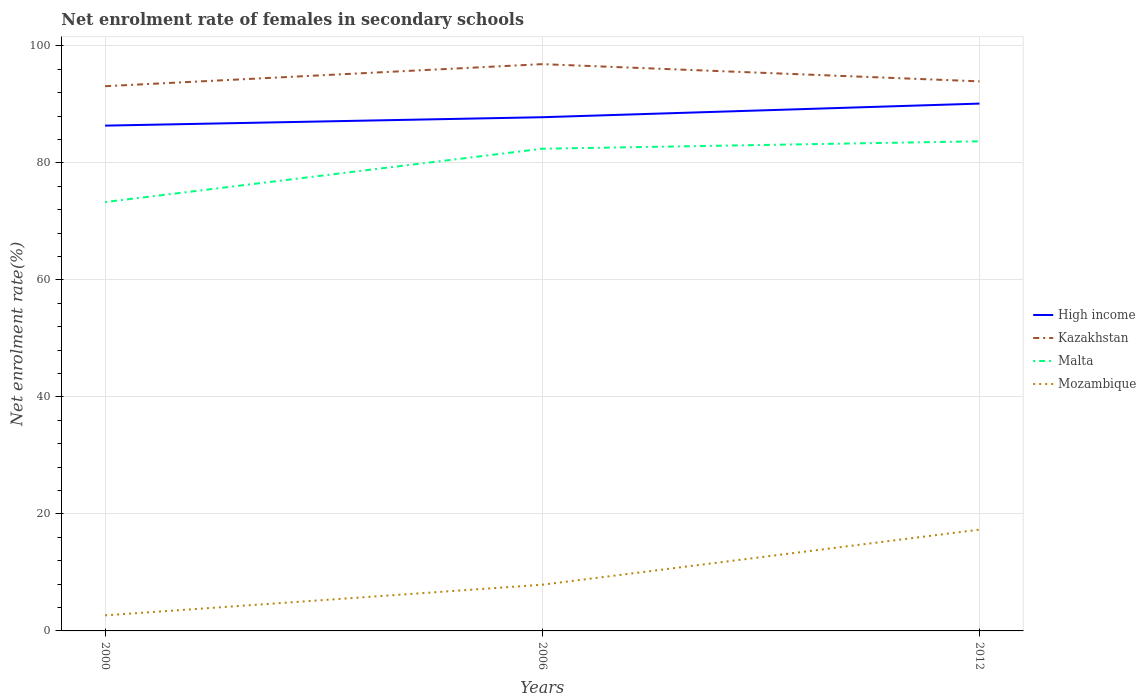How many different coloured lines are there?
Provide a short and direct response. 4. Is the number of lines equal to the number of legend labels?
Your answer should be compact. Yes. Across all years, what is the maximum net enrolment rate of females in secondary schools in High income?
Ensure brevity in your answer.  86.38. In which year was the net enrolment rate of females in secondary schools in Malta maximum?
Provide a short and direct response. 2000. What is the total net enrolment rate of females in secondary schools in Mozambique in the graph?
Your answer should be compact. -9.42. What is the difference between the highest and the second highest net enrolment rate of females in secondary schools in High income?
Your answer should be very brief. 3.76. Is the net enrolment rate of females in secondary schools in Malta strictly greater than the net enrolment rate of females in secondary schools in Mozambique over the years?
Provide a succinct answer. No. How many lines are there?
Provide a succinct answer. 4. How many years are there in the graph?
Provide a succinct answer. 3. How are the legend labels stacked?
Offer a terse response. Vertical. What is the title of the graph?
Your answer should be compact. Net enrolment rate of females in secondary schools. Does "Latin America(all income levels)" appear as one of the legend labels in the graph?
Make the answer very short. No. What is the label or title of the Y-axis?
Your answer should be compact. Net enrolment rate(%). What is the Net enrolment rate(%) in High income in 2000?
Your answer should be very brief. 86.38. What is the Net enrolment rate(%) of Kazakhstan in 2000?
Offer a terse response. 93.11. What is the Net enrolment rate(%) of Malta in 2000?
Offer a terse response. 73.31. What is the Net enrolment rate(%) of Mozambique in 2000?
Ensure brevity in your answer.  2.66. What is the Net enrolment rate(%) of High income in 2006?
Offer a very short reply. 87.81. What is the Net enrolment rate(%) of Kazakhstan in 2006?
Provide a succinct answer. 96.89. What is the Net enrolment rate(%) of Malta in 2006?
Keep it short and to the point. 82.43. What is the Net enrolment rate(%) of Mozambique in 2006?
Keep it short and to the point. 7.9. What is the Net enrolment rate(%) in High income in 2012?
Give a very brief answer. 90.14. What is the Net enrolment rate(%) in Kazakhstan in 2012?
Ensure brevity in your answer.  93.94. What is the Net enrolment rate(%) in Malta in 2012?
Offer a very short reply. 83.7. What is the Net enrolment rate(%) in Mozambique in 2012?
Offer a very short reply. 17.32. Across all years, what is the maximum Net enrolment rate(%) in High income?
Offer a terse response. 90.14. Across all years, what is the maximum Net enrolment rate(%) of Kazakhstan?
Keep it short and to the point. 96.89. Across all years, what is the maximum Net enrolment rate(%) in Malta?
Your response must be concise. 83.7. Across all years, what is the maximum Net enrolment rate(%) of Mozambique?
Give a very brief answer. 17.32. Across all years, what is the minimum Net enrolment rate(%) of High income?
Give a very brief answer. 86.38. Across all years, what is the minimum Net enrolment rate(%) in Kazakhstan?
Provide a short and direct response. 93.11. Across all years, what is the minimum Net enrolment rate(%) in Malta?
Provide a succinct answer. 73.31. Across all years, what is the minimum Net enrolment rate(%) in Mozambique?
Offer a very short reply. 2.66. What is the total Net enrolment rate(%) in High income in the graph?
Give a very brief answer. 264.33. What is the total Net enrolment rate(%) of Kazakhstan in the graph?
Keep it short and to the point. 283.95. What is the total Net enrolment rate(%) in Malta in the graph?
Give a very brief answer. 239.43. What is the total Net enrolment rate(%) of Mozambique in the graph?
Keep it short and to the point. 27.87. What is the difference between the Net enrolment rate(%) in High income in 2000 and that in 2006?
Your response must be concise. -1.44. What is the difference between the Net enrolment rate(%) of Kazakhstan in 2000 and that in 2006?
Provide a succinct answer. -3.77. What is the difference between the Net enrolment rate(%) in Malta in 2000 and that in 2006?
Make the answer very short. -9.12. What is the difference between the Net enrolment rate(%) of Mozambique in 2000 and that in 2006?
Keep it short and to the point. -5.24. What is the difference between the Net enrolment rate(%) of High income in 2000 and that in 2012?
Your response must be concise. -3.76. What is the difference between the Net enrolment rate(%) in Kazakhstan in 2000 and that in 2012?
Ensure brevity in your answer.  -0.83. What is the difference between the Net enrolment rate(%) of Malta in 2000 and that in 2012?
Provide a succinct answer. -10.39. What is the difference between the Net enrolment rate(%) in Mozambique in 2000 and that in 2012?
Your answer should be compact. -14.65. What is the difference between the Net enrolment rate(%) in High income in 2006 and that in 2012?
Offer a very short reply. -2.33. What is the difference between the Net enrolment rate(%) in Kazakhstan in 2006 and that in 2012?
Provide a short and direct response. 2.94. What is the difference between the Net enrolment rate(%) of Malta in 2006 and that in 2012?
Provide a succinct answer. -1.27. What is the difference between the Net enrolment rate(%) of Mozambique in 2006 and that in 2012?
Keep it short and to the point. -9.42. What is the difference between the Net enrolment rate(%) of High income in 2000 and the Net enrolment rate(%) of Kazakhstan in 2006?
Keep it short and to the point. -10.51. What is the difference between the Net enrolment rate(%) of High income in 2000 and the Net enrolment rate(%) of Malta in 2006?
Give a very brief answer. 3.95. What is the difference between the Net enrolment rate(%) of High income in 2000 and the Net enrolment rate(%) of Mozambique in 2006?
Your answer should be very brief. 78.48. What is the difference between the Net enrolment rate(%) in Kazakhstan in 2000 and the Net enrolment rate(%) in Malta in 2006?
Provide a succinct answer. 10.69. What is the difference between the Net enrolment rate(%) in Kazakhstan in 2000 and the Net enrolment rate(%) in Mozambique in 2006?
Keep it short and to the point. 85.22. What is the difference between the Net enrolment rate(%) in Malta in 2000 and the Net enrolment rate(%) in Mozambique in 2006?
Make the answer very short. 65.41. What is the difference between the Net enrolment rate(%) in High income in 2000 and the Net enrolment rate(%) in Kazakhstan in 2012?
Your answer should be very brief. -7.57. What is the difference between the Net enrolment rate(%) of High income in 2000 and the Net enrolment rate(%) of Malta in 2012?
Give a very brief answer. 2.68. What is the difference between the Net enrolment rate(%) of High income in 2000 and the Net enrolment rate(%) of Mozambique in 2012?
Keep it short and to the point. 69.06. What is the difference between the Net enrolment rate(%) of Kazakhstan in 2000 and the Net enrolment rate(%) of Malta in 2012?
Your answer should be very brief. 9.42. What is the difference between the Net enrolment rate(%) of Kazakhstan in 2000 and the Net enrolment rate(%) of Mozambique in 2012?
Your response must be concise. 75.8. What is the difference between the Net enrolment rate(%) of Malta in 2000 and the Net enrolment rate(%) of Mozambique in 2012?
Your answer should be compact. 55.99. What is the difference between the Net enrolment rate(%) in High income in 2006 and the Net enrolment rate(%) in Kazakhstan in 2012?
Give a very brief answer. -6.13. What is the difference between the Net enrolment rate(%) of High income in 2006 and the Net enrolment rate(%) of Malta in 2012?
Give a very brief answer. 4.11. What is the difference between the Net enrolment rate(%) of High income in 2006 and the Net enrolment rate(%) of Mozambique in 2012?
Provide a short and direct response. 70.5. What is the difference between the Net enrolment rate(%) in Kazakhstan in 2006 and the Net enrolment rate(%) in Malta in 2012?
Ensure brevity in your answer.  13.19. What is the difference between the Net enrolment rate(%) in Kazakhstan in 2006 and the Net enrolment rate(%) in Mozambique in 2012?
Provide a short and direct response. 79.57. What is the difference between the Net enrolment rate(%) in Malta in 2006 and the Net enrolment rate(%) in Mozambique in 2012?
Keep it short and to the point. 65.11. What is the average Net enrolment rate(%) in High income per year?
Offer a terse response. 88.11. What is the average Net enrolment rate(%) in Kazakhstan per year?
Provide a short and direct response. 94.65. What is the average Net enrolment rate(%) of Malta per year?
Keep it short and to the point. 79.81. What is the average Net enrolment rate(%) of Mozambique per year?
Provide a succinct answer. 9.29. In the year 2000, what is the difference between the Net enrolment rate(%) in High income and Net enrolment rate(%) in Kazakhstan?
Give a very brief answer. -6.74. In the year 2000, what is the difference between the Net enrolment rate(%) of High income and Net enrolment rate(%) of Malta?
Offer a very short reply. 13.07. In the year 2000, what is the difference between the Net enrolment rate(%) in High income and Net enrolment rate(%) in Mozambique?
Offer a very short reply. 83.71. In the year 2000, what is the difference between the Net enrolment rate(%) in Kazakhstan and Net enrolment rate(%) in Malta?
Make the answer very short. 19.81. In the year 2000, what is the difference between the Net enrolment rate(%) of Kazakhstan and Net enrolment rate(%) of Mozambique?
Offer a very short reply. 90.45. In the year 2000, what is the difference between the Net enrolment rate(%) in Malta and Net enrolment rate(%) in Mozambique?
Your response must be concise. 70.65. In the year 2006, what is the difference between the Net enrolment rate(%) of High income and Net enrolment rate(%) of Kazakhstan?
Offer a terse response. -9.07. In the year 2006, what is the difference between the Net enrolment rate(%) in High income and Net enrolment rate(%) in Malta?
Make the answer very short. 5.39. In the year 2006, what is the difference between the Net enrolment rate(%) of High income and Net enrolment rate(%) of Mozambique?
Provide a succinct answer. 79.92. In the year 2006, what is the difference between the Net enrolment rate(%) of Kazakhstan and Net enrolment rate(%) of Malta?
Ensure brevity in your answer.  14.46. In the year 2006, what is the difference between the Net enrolment rate(%) of Kazakhstan and Net enrolment rate(%) of Mozambique?
Your answer should be very brief. 88.99. In the year 2006, what is the difference between the Net enrolment rate(%) of Malta and Net enrolment rate(%) of Mozambique?
Provide a succinct answer. 74.53. In the year 2012, what is the difference between the Net enrolment rate(%) in High income and Net enrolment rate(%) in Kazakhstan?
Provide a succinct answer. -3.8. In the year 2012, what is the difference between the Net enrolment rate(%) of High income and Net enrolment rate(%) of Malta?
Provide a succinct answer. 6.44. In the year 2012, what is the difference between the Net enrolment rate(%) in High income and Net enrolment rate(%) in Mozambique?
Provide a succinct answer. 72.82. In the year 2012, what is the difference between the Net enrolment rate(%) in Kazakhstan and Net enrolment rate(%) in Malta?
Offer a terse response. 10.25. In the year 2012, what is the difference between the Net enrolment rate(%) in Kazakhstan and Net enrolment rate(%) in Mozambique?
Provide a succinct answer. 76.63. In the year 2012, what is the difference between the Net enrolment rate(%) in Malta and Net enrolment rate(%) in Mozambique?
Provide a succinct answer. 66.38. What is the ratio of the Net enrolment rate(%) of High income in 2000 to that in 2006?
Make the answer very short. 0.98. What is the ratio of the Net enrolment rate(%) in Kazakhstan in 2000 to that in 2006?
Your answer should be very brief. 0.96. What is the ratio of the Net enrolment rate(%) in Malta in 2000 to that in 2006?
Give a very brief answer. 0.89. What is the ratio of the Net enrolment rate(%) of Mozambique in 2000 to that in 2006?
Give a very brief answer. 0.34. What is the ratio of the Net enrolment rate(%) of High income in 2000 to that in 2012?
Provide a succinct answer. 0.96. What is the ratio of the Net enrolment rate(%) of Kazakhstan in 2000 to that in 2012?
Offer a terse response. 0.99. What is the ratio of the Net enrolment rate(%) in Malta in 2000 to that in 2012?
Provide a short and direct response. 0.88. What is the ratio of the Net enrolment rate(%) in Mozambique in 2000 to that in 2012?
Provide a short and direct response. 0.15. What is the ratio of the Net enrolment rate(%) in High income in 2006 to that in 2012?
Your response must be concise. 0.97. What is the ratio of the Net enrolment rate(%) in Kazakhstan in 2006 to that in 2012?
Your answer should be compact. 1.03. What is the ratio of the Net enrolment rate(%) of Mozambique in 2006 to that in 2012?
Your response must be concise. 0.46. What is the difference between the highest and the second highest Net enrolment rate(%) in High income?
Make the answer very short. 2.33. What is the difference between the highest and the second highest Net enrolment rate(%) in Kazakhstan?
Give a very brief answer. 2.94. What is the difference between the highest and the second highest Net enrolment rate(%) of Malta?
Make the answer very short. 1.27. What is the difference between the highest and the second highest Net enrolment rate(%) in Mozambique?
Give a very brief answer. 9.42. What is the difference between the highest and the lowest Net enrolment rate(%) of High income?
Your response must be concise. 3.76. What is the difference between the highest and the lowest Net enrolment rate(%) in Kazakhstan?
Provide a short and direct response. 3.77. What is the difference between the highest and the lowest Net enrolment rate(%) in Malta?
Ensure brevity in your answer.  10.39. What is the difference between the highest and the lowest Net enrolment rate(%) of Mozambique?
Provide a short and direct response. 14.65. 